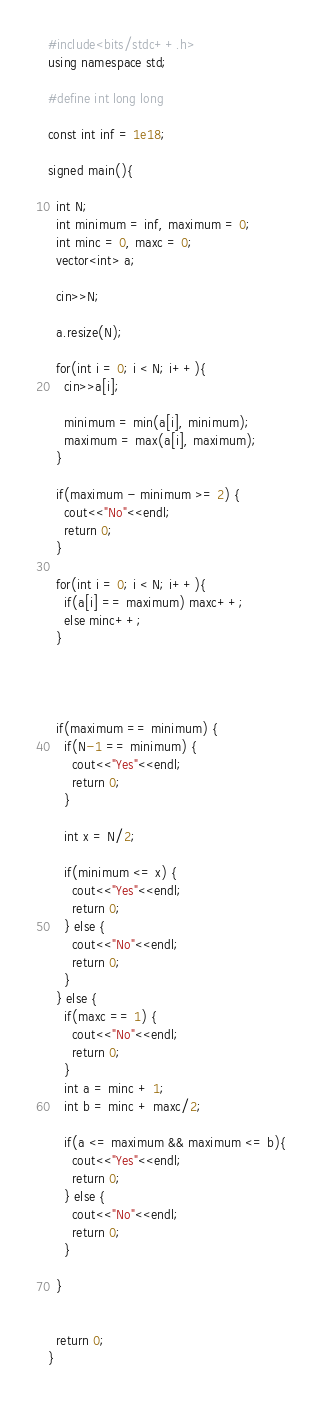<code> <loc_0><loc_0><loc_500><loc_500><_C++_>#include<bits/stdc++.h>
using namespace std;

#define int long long

const int inf = 1e18;

signed main(){

  int N;
  int minimum = inf, maximum = 0;
  int minc = 0, maxc = 0;
  vector<int> a;

  cin>>N;

  a.resize(N);

  for(int i = 0; i < N; i++){
    cin>>a[i];

    minimum = min(a[i], minimum);
    maximum = max(a[i], maximum);
  }

  if(maximum - minimum >= 2) {
    cout<<"No"<<endl;
    return 0;
  }

  for(int i = 0; i < N; i++){
    if(a[i] == maximum) maxc++;
    else minc++;
  }




  if(maximum == minimum) {
    if(N-1 == minimum) {
      cout<<"Yes"<<endl;
      return 0;
    }

    int x = N/2;

    if(minimum <= x) {
      cout<<"Yes"<<endl;
      return 0;
    } else {
      cout<<"No"<<endl;
      return 0;
    }
  } else {
    if(maxc == 1) {
      cout<<"No"<<endl;
      return 0;
    }
    int a = minc + 1;
    int b = minc + maxc/2;

    if(a <= maximum && maximum <= b){
      cout<<"Yes"<<endl;
      return 0;
    } else {
      cout<<"No"<<endl;
      return 0;
    }

  }


  return 0;
}
</code> 